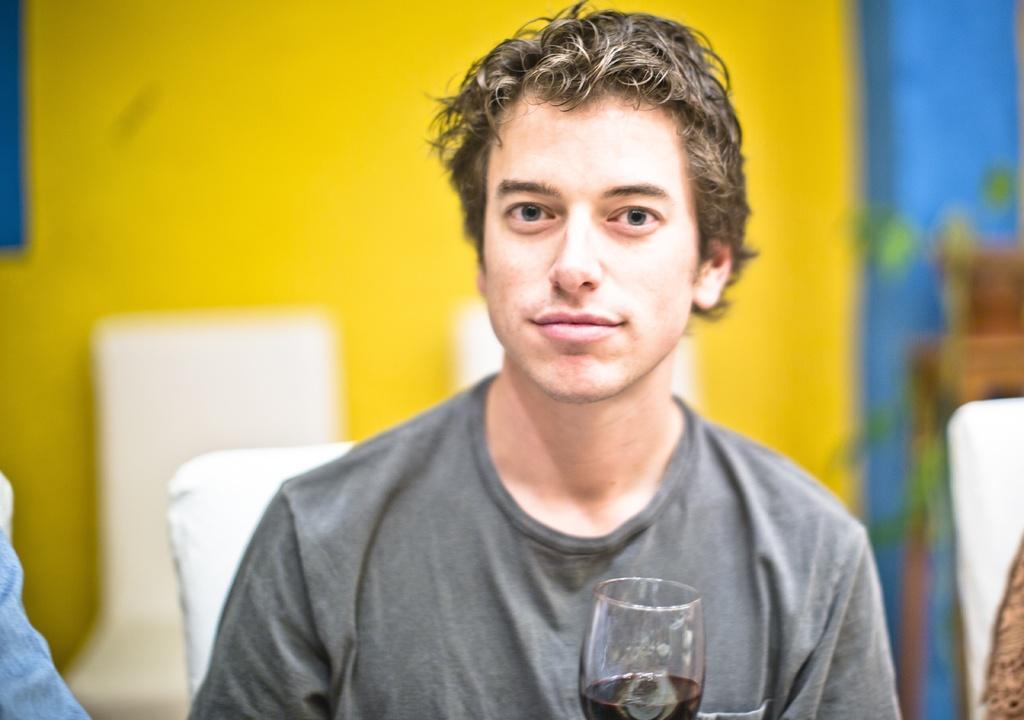Could you give a brief overview of what you see in this image? In the image there is a man, he is holding a glass with some drink and the background of the man is blurry and he is wearing grey t-shirt. 